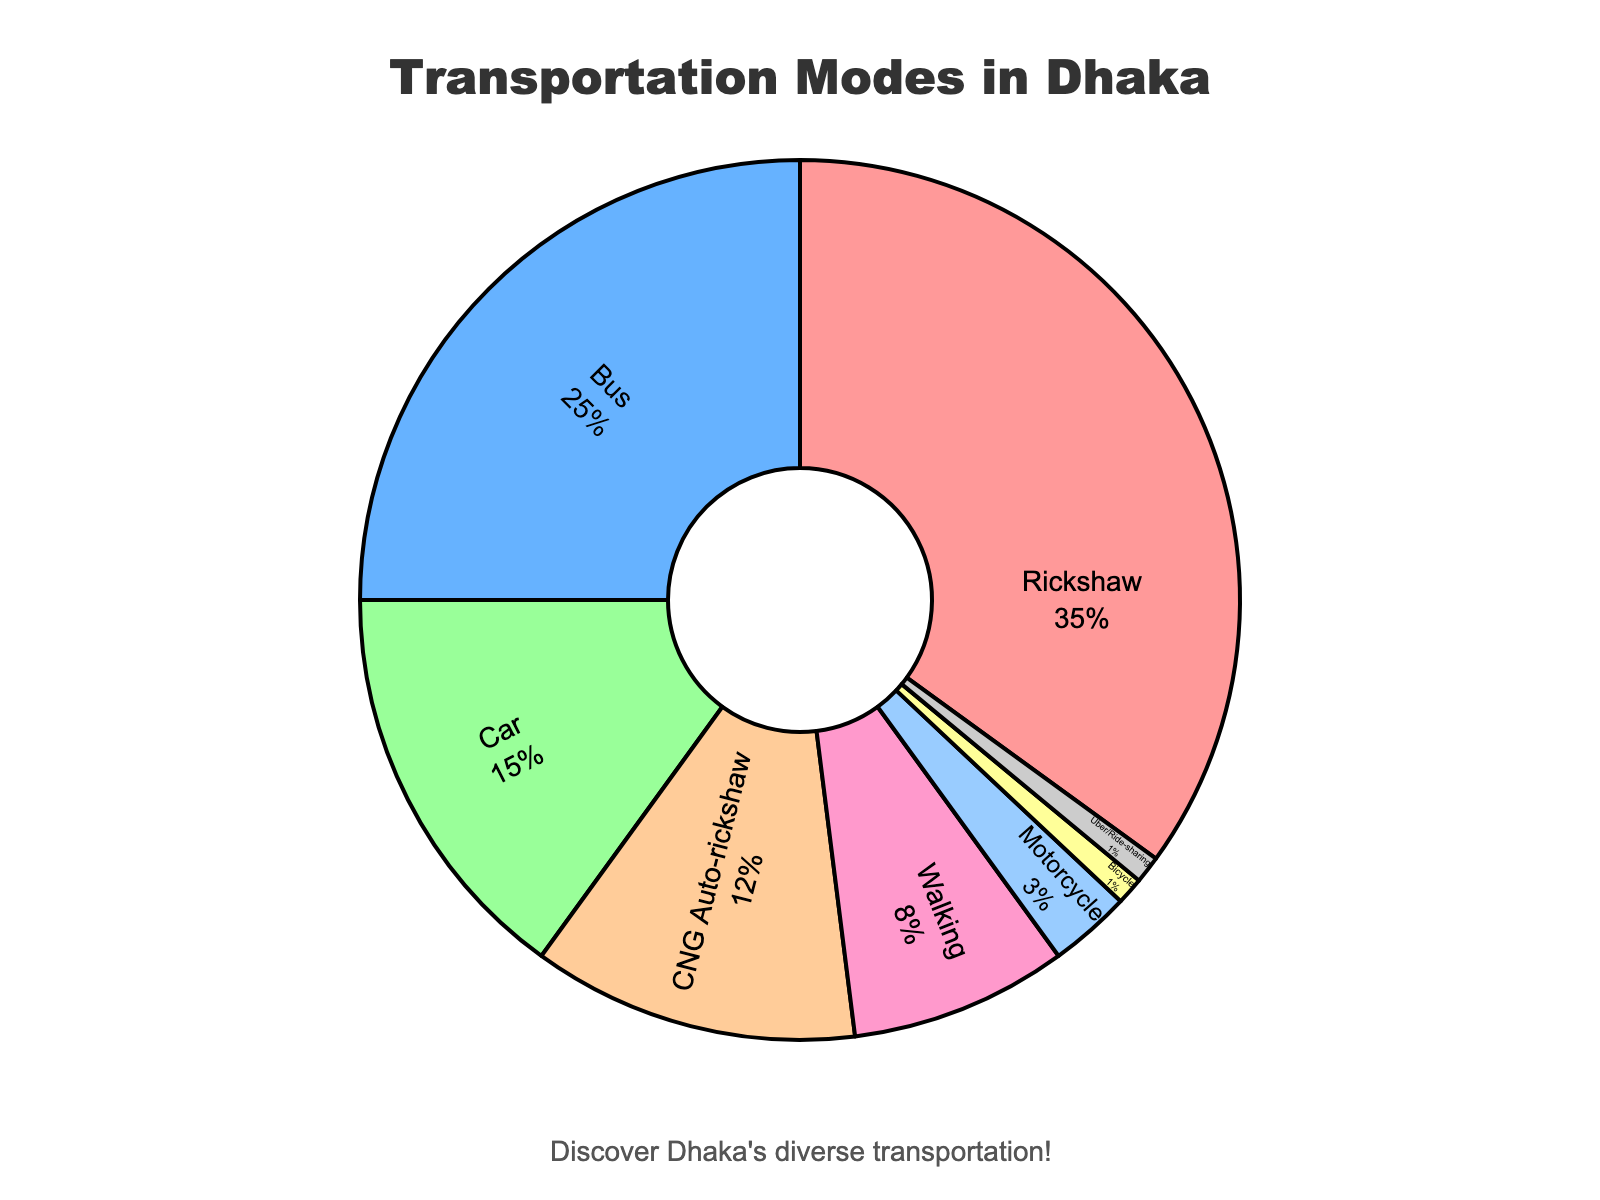What is the most popular transportation mode in Dhaka? The section with the largest percentage represents the most popular transportation mode. According to the pie chart, Rickshaw occupies the largest portion with 35%.
Answer: Rickshaw Which transportation mode is used less frequently, CNG Auto-rickshaw or Walking? Compare the segments for CNG Auto-rickshaw and Walking: CNG Auto-rickshaw is at 12%, while Walking is at 8%, making Walking less frequent.
Answer: Walking What is the combined percentage for Car and Bus modes? Add the percentages of Car and Bus: 15% (Car) + 25% (Bus) = 40%.
Answer: 40% How much more popular is Rickshaw compared to Car? Subtract the percentage of Car from Rickshaw: 35% (Rickshaw) - 15% (Car) = 20%.
Answer: 20% What percentage of people use personalized transportation modes (Car, Motorcycle, Bicycle, Uber/Ride-sharing)? Add up the percentages for Car, Motorcycle, Bicycle, and Uber/Ride-sharing: 15% (Car) + 3% (Motorcycle) + 1% (Bicycle) + 1% (Uber/Ride-sharing) = 20%.
Answer: 20% How does the usage of Bus compare to the combined usage of CNG Auto-rickshaw and Walking? Add the percentages of CNG Auto-rickshaw and Walking: 12% + 8% = 20%. Compare this to the percentage of Bus, which is 25%. Bus is more by 5 percentage points.
Answer: Bus is more by 5% What proportion of the chart is occupied by non-motorized transportation modes (Rickshaw, Walking, Bicycle)? Add up the percentages for Rickshaw, Walking, and Bicycle: 35% (Rickshaw) + 8% (Walking) + 1% (Bicycle) = 44%.
Answer: 44% Which transportation modes have the same percentage usage? Compare the percentage values, and both Bicycle and Uber/Ride-sharing show 1%.
Answer: Bicycle and Uber/Ride-sharing If the total percentage of modes other than Rickshaw is considered, what would that be? Subtract the percentage of Rickshaw from 100%: 100% - 35% = 65%.
Answer: 65% 